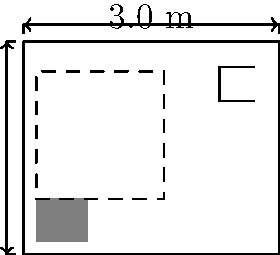As a property manager, you are reviewing plans for a new accessible bathroom. The layout shows a toilet, sink, and clear floor space. Given that the minimum clear floor space required is 1.5 m x 1.5 m, what is the minimum area (in square meters) needed for this accessible bathroom layout? To determine the minimum area needed for this accessible bathroom layout, we need to follow these steps:

1. Identify the key components:
   - Toilet
   - Sink
   - Clear floor space (minimum 1.5 m x 1.5 m)

2. Analyze the layout:
   - The clear floor space is positioned to accommodate both the toilet and sink access.
   - The room dimensions must be large enough to fit all components and the required clear floor space.

3. Determine the minimum dimensions:
   - Width: The room must be at least as wide as the clear floor space, which is 1.5 m.
   - Length: The room must accommodate the toilet depth, clear floor space, and some space for the sink.
     Estimated minimum length: 0.7 m (toilet) + 1.5 m (clear space) + 0.3 m (sink area) = 2.5 m

4. Calculate the minimum area:
   $$\text{Minimum Area} = \text{Width} \times \text{Length}$$
   $$\text{Minimum Area} = 1.5 \text{ m} \times 2.5 \text{ m} = 3.75 \text{ m}^2$$

Therefore, the minimum area needed for this accessible bathroom layout is 3.75 square meters.
Answer: 3.75 m² 